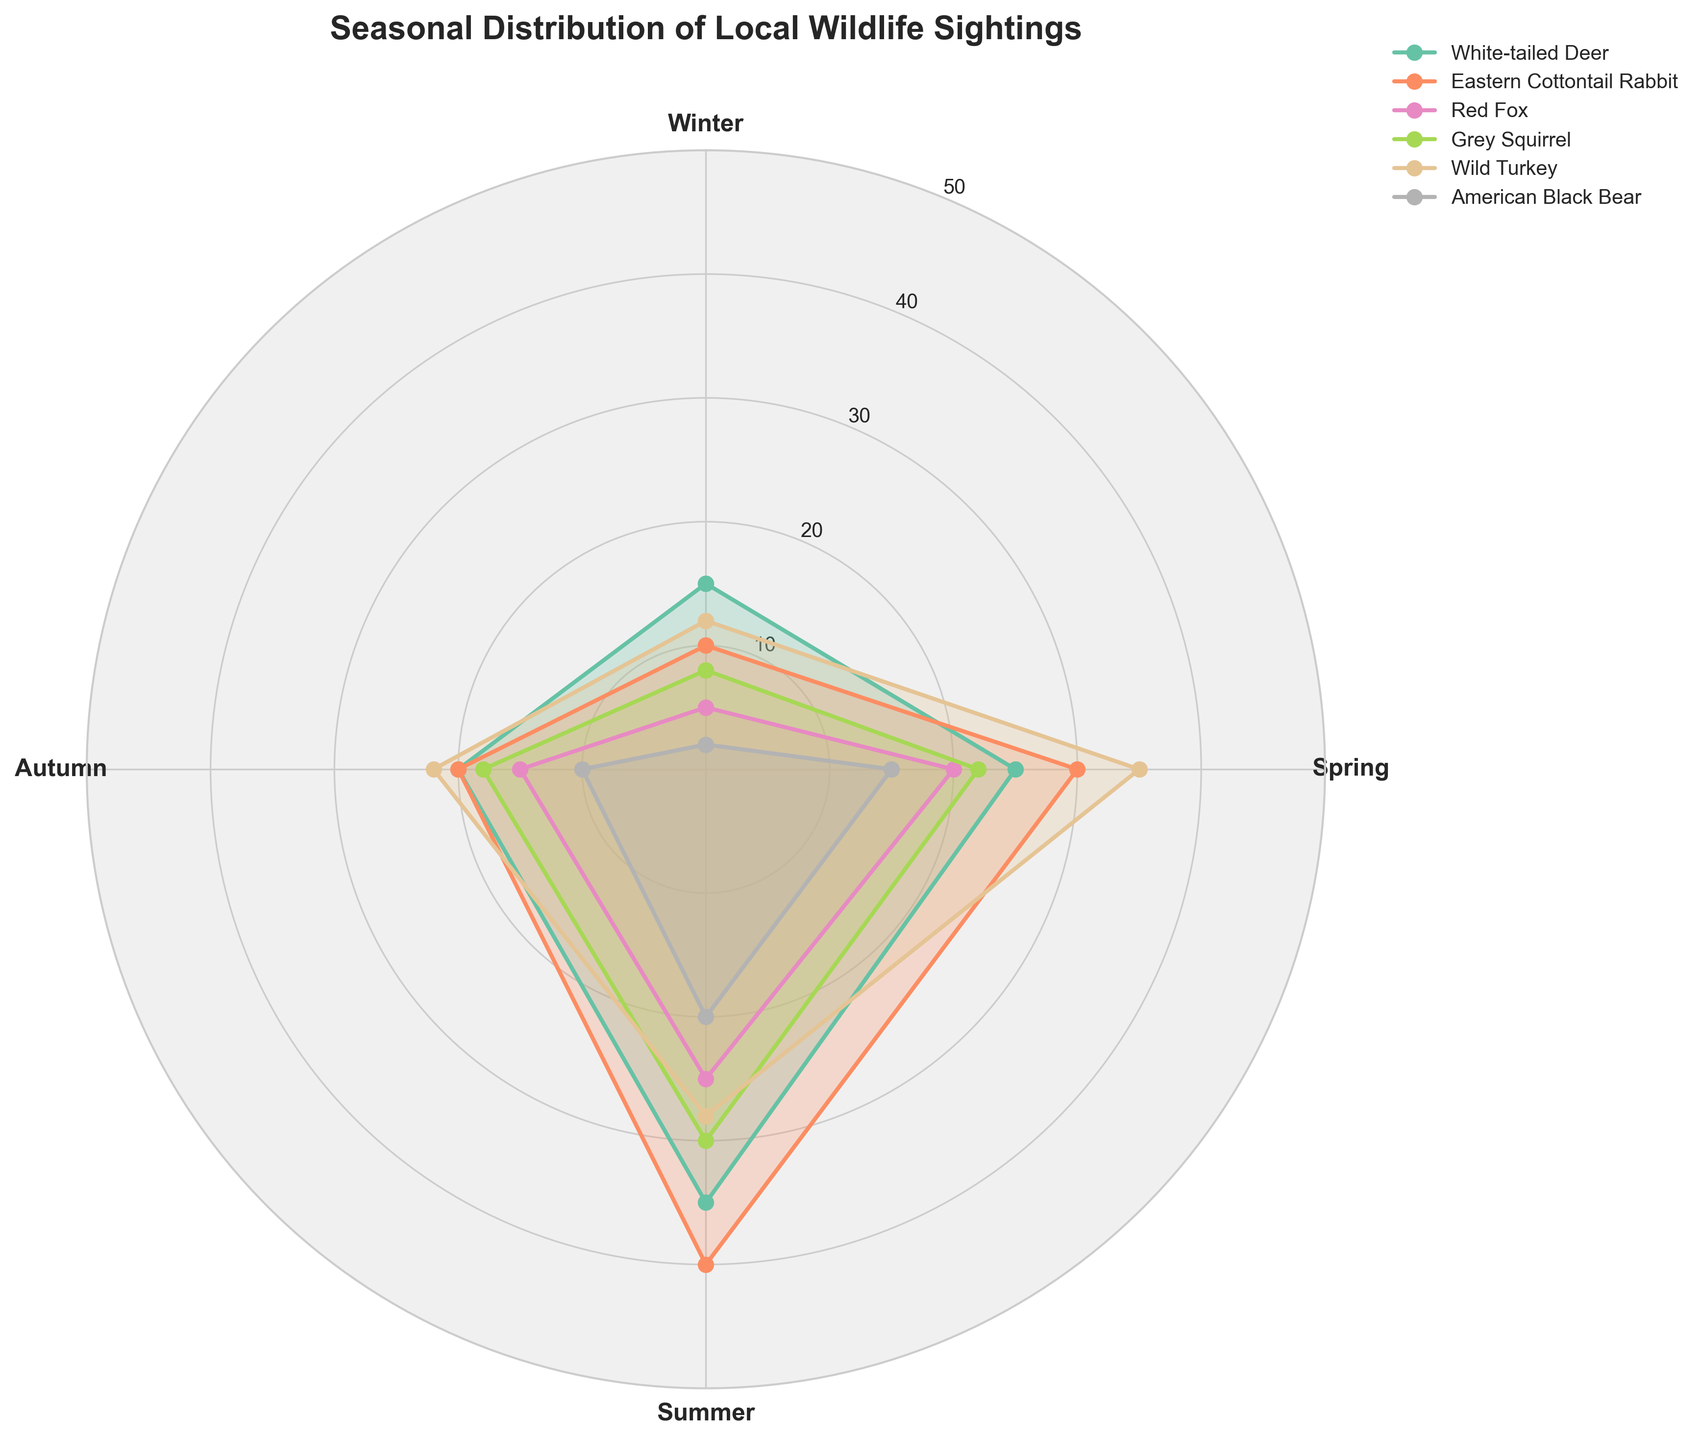What is the highest number of sightings for any species in the Summer? The chart shows the data points for each species across all seasons. By looking at the Summer segment, the Eastern Cottontail Rabbit has the highest number of sightings with 40.
Answer: 40 Which species has the least sightings in Winter? By comparing the data points in the Winter segment, the American Black Bear has the least sightings with 2.
Answer: American Black Bear How many species have more sightings in Spring than in Autumn? By comparing the Spring and Autumn segments for each species, White-tailed Deer, Red Fox, Grey Squirrel, and Wild Turkey have more sightings in Spring than in Autumn. This gives us a total of 4 species.
Answer: 4 species What is the average number of sightings for the White-tailed Deer across all seasons? The sightings for the White-tailed Deer across Winter, Spring, Summer, and Autumn are 15, 25, 35, and 20 respectively. The sum is 95 and the average is 95 / 4 = 23.75.
Answer: 23.75 Compare the sightings of the Wild Turkey and the Red Fox in Autumn. Which species has more sightings and by how much? In the Autumn segment, the Wild Turkey has 22 sightings and the Red Fox has 15. Thus, the Wild Turkey has 22 - 15 = 7 more sightings than the Red Fox.
Answer: Wild Turkey by 7 Which species shows the most consistent distribution of sightings across seasons? By visually examining each species' distribution, the White-tailed Deer seems to have the most consistent pattern, with sightings ranging from 15 to 35 across all seasons. The variation is smaller compared to other species.
Answer: White-tailed Deer During which season do the majority of species have their peak sightings? Examining peaks for each species, most peaks are seen in Summer for White-tailed Deer, Eastern Cottontail Rabbit, Red Fox, and Grey Squirrel, indicating that the majority of species have their peak sightings in Summer.
Answer: Summer 